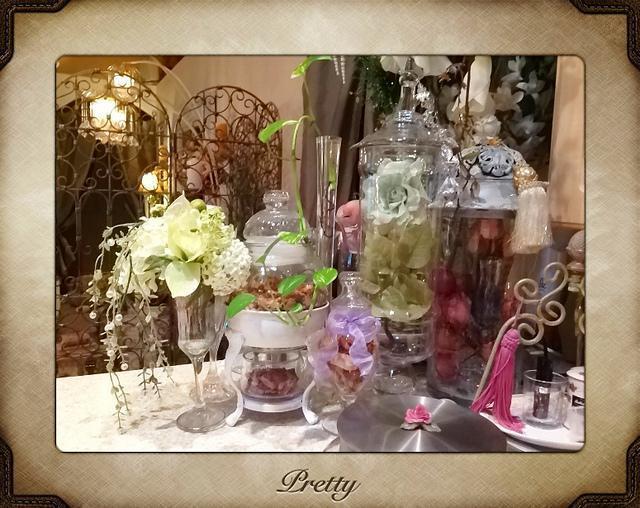How many vases are there?
Give a very brief answer. 5. How many clear bottles are there in the image?
Give a very brief answer. 0. 